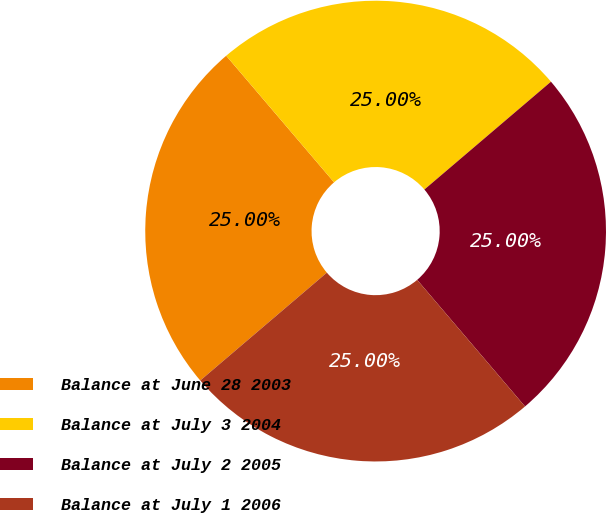Convert chart. <chart><loc_0><loc_0><loc_500><loc_500><pie_chart><fcel>Balance at June 28 2003<fcel>Balance at July 3 2004<fcel>Balance at July 2 2005<fcel>Balance at July 1 2006<nl><fcel>25.0%<fcel>25.0%<fcel>25.0%<fcel>25.0%<nl></chart> 